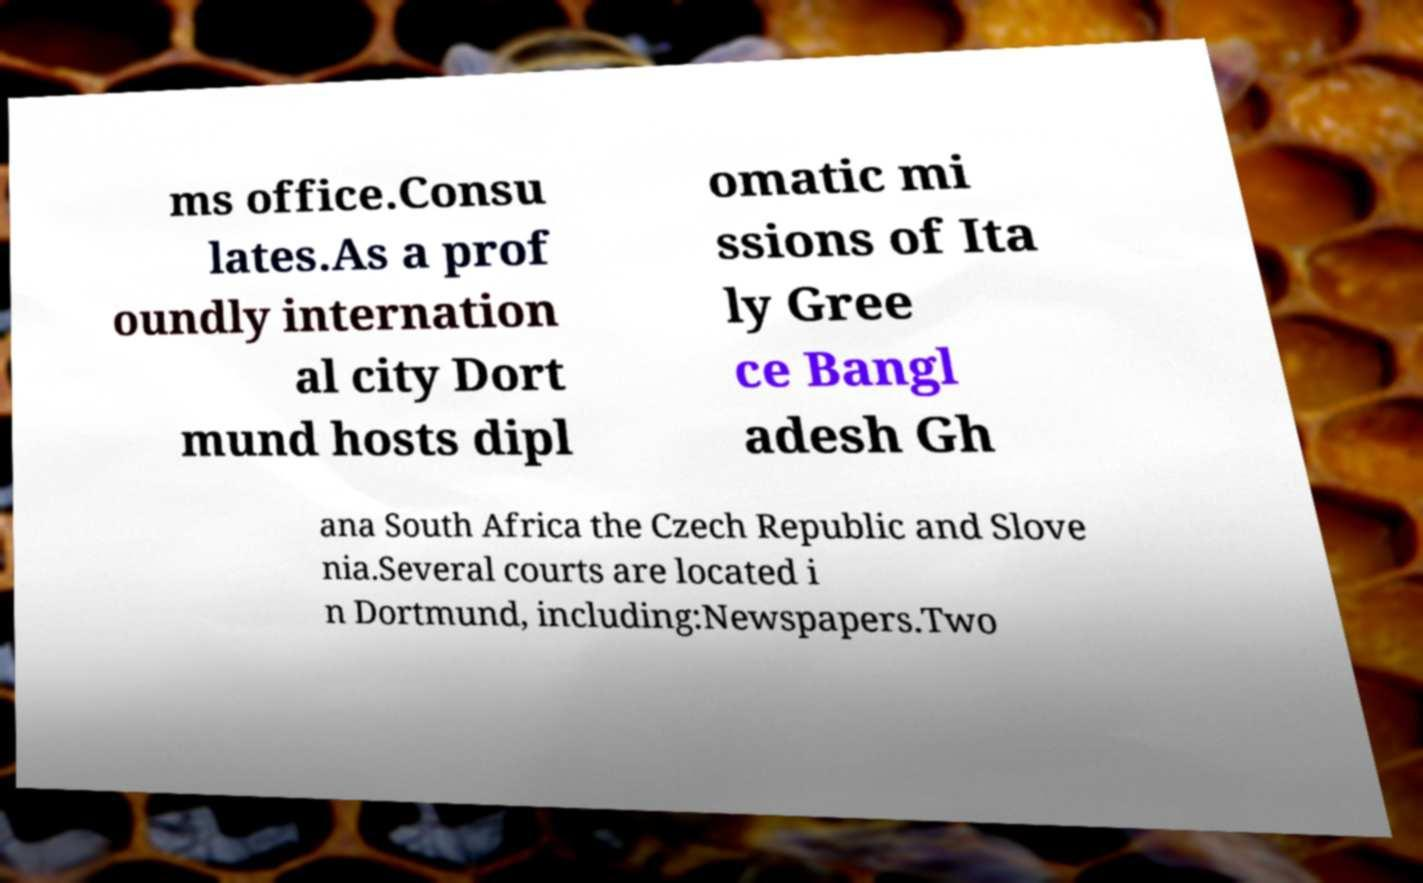Can you accurately transcribe the text from the provided image for me? ms office.Consu lates.As a prof oundly internation al city Dort mund hosts dipl omatic mi ssions of Ita ly Gree ce Bangl adesh Gh ana South Africa the Czech Republic and Slove nia.Several courts are located i n Dortmund, including:Newspapers.Two 